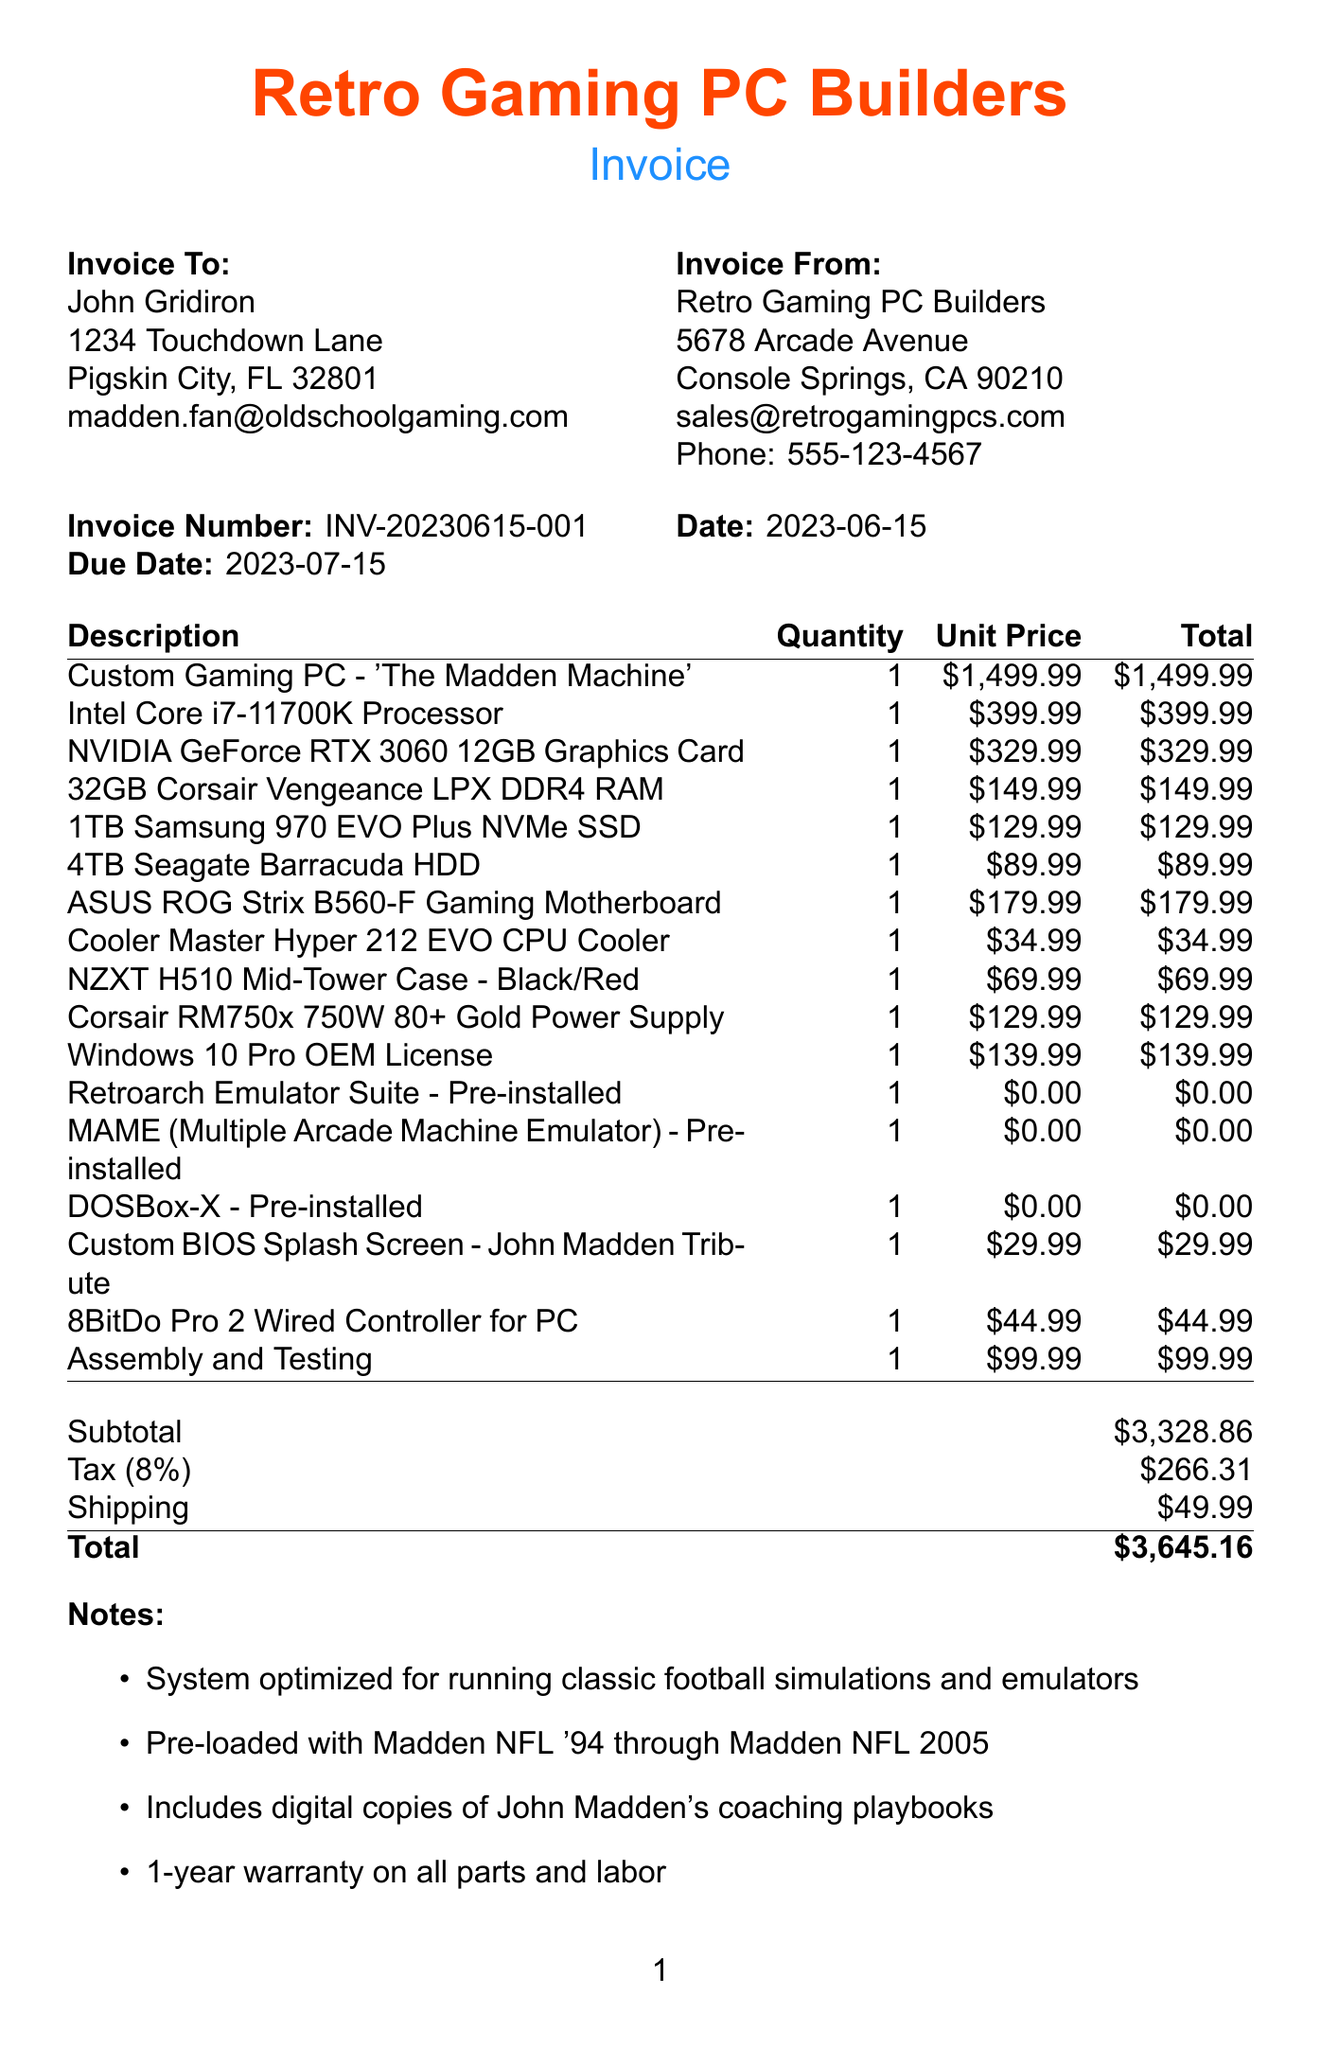what is the invoice number? The invoice number is a unique identifier for the transaction, which is mentioned at the top of the document.
Answer: INV-20230615-001 who is the customer? The document provides the name and contact information of the person who made the purchase.
Answer: John Gridiron what is the total amount due? The total amount is the final sum of all items including tax and shipping costs listed at the bottom of the invoice.
Answer: $3,645.16 what is the tax rate applied in this invoice? The tax rate can be found in the document stating the percentage applied to the subtotal.
Answer: 8% what items are pre-installed on the gaming PC? The document lists specific software that has been pre-installed on the custom gaming PC.
Answer: Retroarch Emulator Suite, MAME, DOSBox-X how many days do I have to return the product? The return policy is specified in the notes section of the document, highlighting the timeframe for returns.
Answer: 30-day who is the seller? The seller's information is provided near the top of the document, including their name and address.
Answer: Retro Gaming PC Builders what type of payment methods are accepted? The document outlines specific ways through which payment can be made for the invoice.
Answer: Credit Card, PayPal, Bank Transfer what is included with the gaming PC regarding warranty? The warranty details are mentioned in the notes section, outlining the protection for the purchase.
Answer: 1-year warranty on all parts and labor 